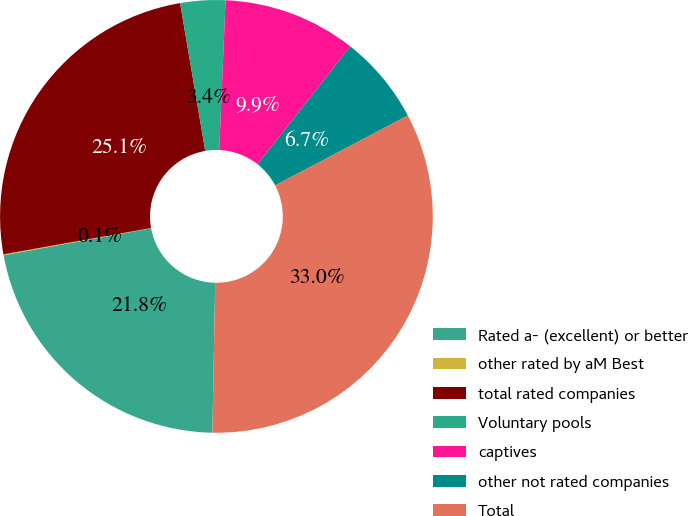<chart> <loc_0><loc_0><loc_500><loc_500><pie_chart><fcel>Rated a- (excellent) or better<fcel>other rated by aM Best<fcel>total rated companies<fcel>Voluntary pools<fcel>captives<fcel>other not rated companies<fcel>Total<nl><fcel>21.83%<fcel>0.07%<fcel>25.12%<fcel>3.36%<fcel>9.95%<fcel>6.66%<fcel>33.02%<nl></chart> 